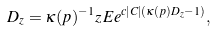<formula> <loc_0><loc_0><loc_500><loc_500>D _ { z } = \kappa ( p ) ^ { - 1 } z \, { E } e ^ { c | C | ( \kappa ( p ) D _ { z } - 1 ) } ,</formula> 